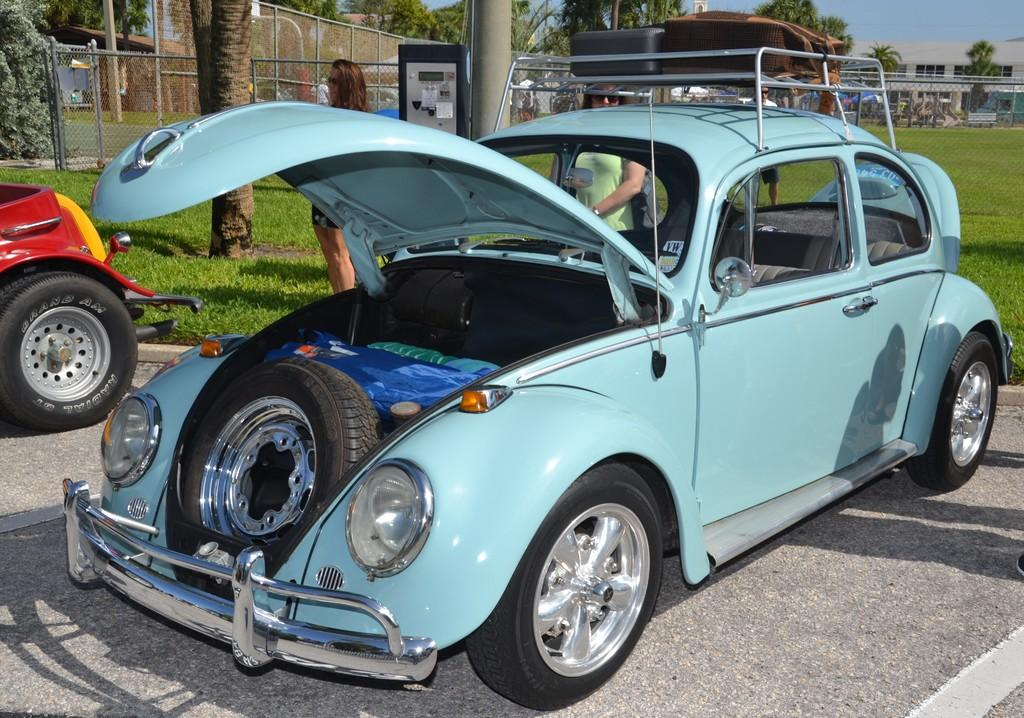How many vehicles are parked on the road in the image? There are two vehicles parked on the road in the image. What can be seen behind the vehicles? There are people, buildings, grass, fencing, and trees behind the vehicles. What is visible in the background of the image? The sky is visible behind the trees. What type of organization is responsible for the destruction of the buildings in the image? There is no destruction of buildings visible in the image; the buildings appear intact. 